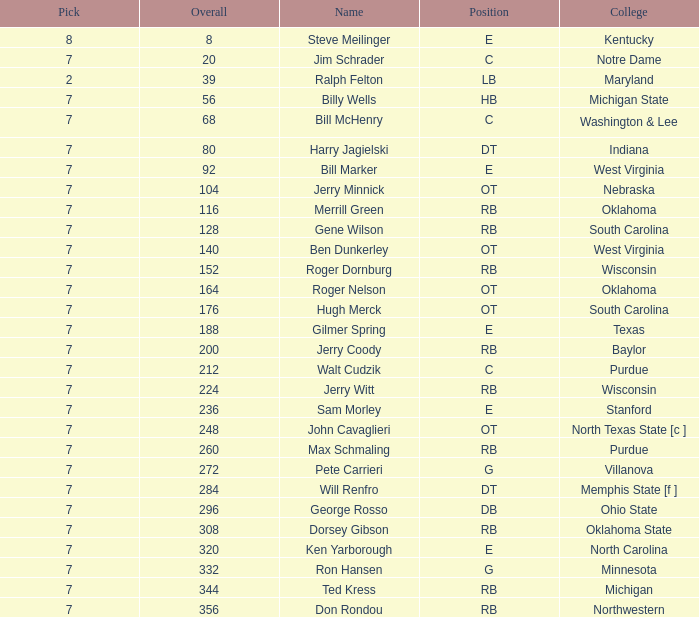What is the number of the round in which Ron Hansen was drafted and the overall is greater than 332? 0.0. 